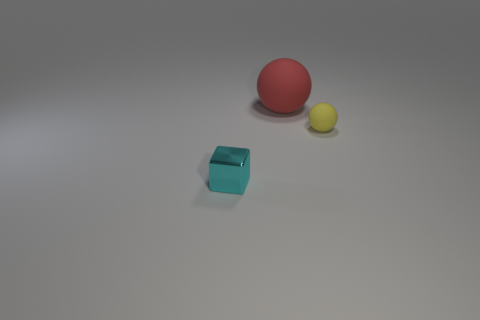Is there any other thing that has the same material as the block?
Your answer should be very brief. No. There is a red matte thing; is its shape the same as the rubber object that is in front of the big thing?
Keep it short and to the point. Yes. What is the material of the ball in front of the matte thing on the left side of the tiny thing to the right of the tiny cyan shiny object?
Your answer should be compact. Rubber. How many large objects are gray rubber things or yellow matte balls?
Make the answer very short. 0. What number of other things are the same size as the red thing?
Your response must be concise. 0. There is a small thing behind the small cyan thing; is it the same shape as the red thing?
Your response must be concise. Yes. There is another matte object that is the same shape as the red thing; what color is it?
Ensure brevity in your answer.  Yellow. Is there any other thing that is the same shape as the small metal object?
Your response must be concise. No. Is the number of small spheres that are to the left of the tiny cyan shiny object the same as the number of big purple matte things?
Offer a terse response. Yes. How many objects are both left of the big red matte ball and to the right of the metal cube?
Give a very brief answer. 0. 